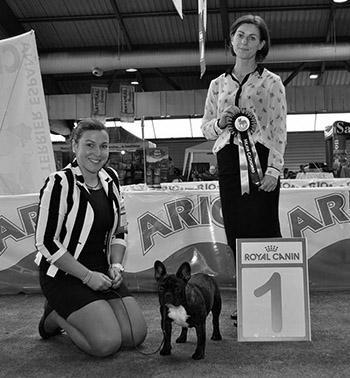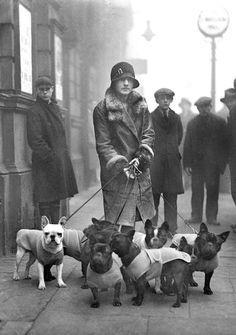The first image is the image on the left, the second image is the image on the right. For the images displayed, is the sentence "A woman is walking multiple dogs on the street." factually correct? Answer yes or no. Yes. The first image is the image on the left, the second image is the image on the right. Evaluate the accuracy of this statement regarding the images: "The right image shows a person standing to one side of two black pugs with white chest marks and holding onto a leash.". Is it true? Answer yes or no. No. 